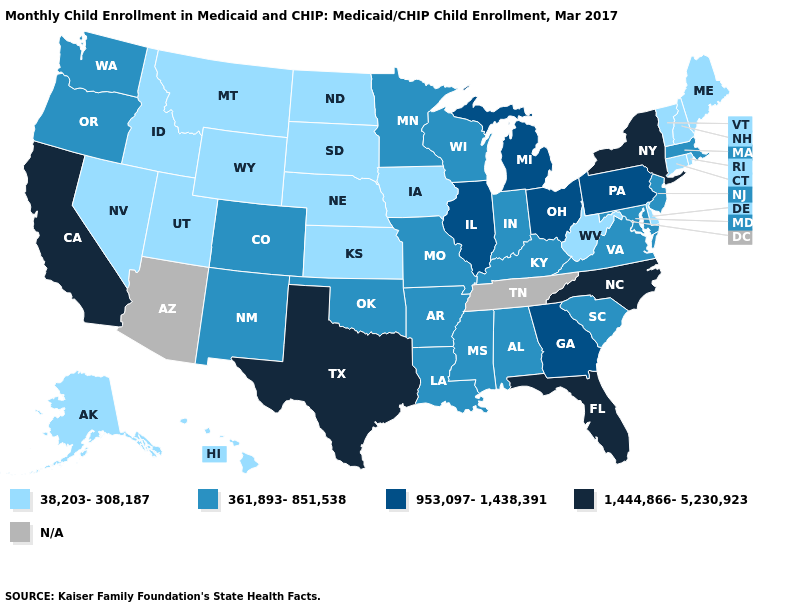What is the value of Ohio?
Write a very short answer. 953,097-1,438,391. What is the value of Hawaii?
Give a very brief answer. 38,203-308,187. What is the value of New Hampshire?
Short answer required. 38,203-308,187. Which states hav the highest value in the Northeast?
Be succinct. New York. What is the value of New York?
Short answer required. 1,444,866-5,230,923. Name the states that have a value in the range 361,893-851,538?
Concise answer only. Alabama, Arkansas, Colorado, Indiana, Kentucky, Louisiana, Maryland, Massachusetts, Minnesota, Mississippi, Missouri, New Jersey, New Mexico, Oklahoma, Oregon, South Carolina, Virginia, Washington, Wisconsin. What is the value of Hawaii?
Short answer required. 38,203-308,187. What is the highest value in the South ?
Short answer required. 1,444,866-5,230,923. Name the states that have a value in the range 361,893-851,538?
Keep it brief. Alabama, Arkansas, Colorado, Indiana, Kentucky, Louisiana, Maryland, Massachusetts, Minnesota, Mississippi, Missouri, New Jersey, New Mexico, Oklahoma, Oregon, South Carolina, Virginia, Washington, Wisconsin. What is the value of Georgia?
Write a very short answer. 953,097-1,438,391. Among the states that border Missouri , which have the highest value?
Concise answer only. Illinois. Does the map have missing data?
Give a very brief answer. Yes. 